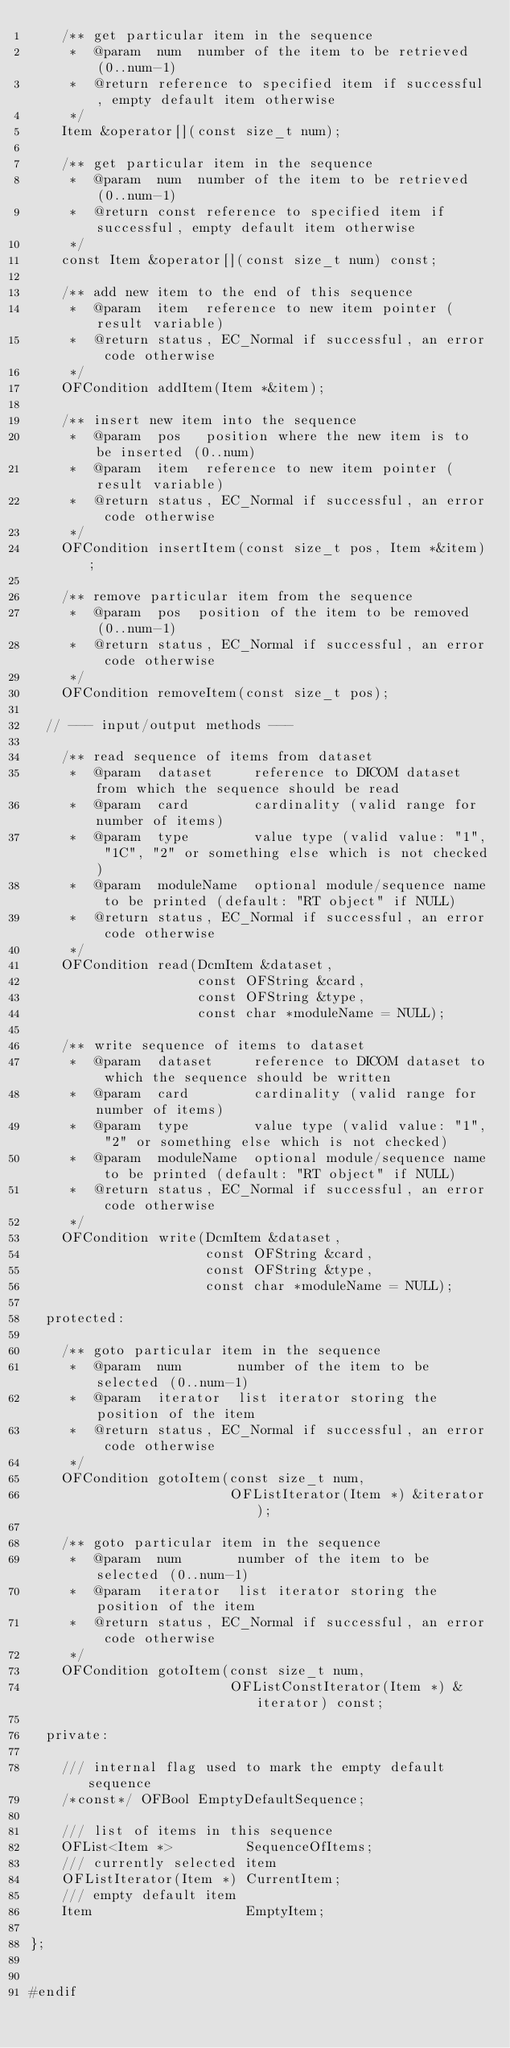<code> <loc_0><loc_0><loc_500><loc_500><_C_>    /** get particular item in the sequence
     *  @param  num  number of the item to be retrieved (0..num-1)
     *  @return reference to specified item if successful, empty default item otherwise
     */
    Item &operator[](const size_t num);

    /** get particular item in the sequence
     *  @param  num  number of the item to be retrieved (0..num-1)
     *  @return const reference to specified item if successful, empty default item otherwise
     */
    const Item &operator[](const size_t num) const;

    /** add new item to the end of this sequence
     *  @param  item  reference to new item pointer (result variable)
     *  @return status, EC_Normal if successful, an error code otherwise
     */
    OFCondition addItem(Item *&item);

    /** insert new item into the sequence
     *  @param  pos   position where the new item is to be inserted (0..num)
     *  @param  item  reference to new item pointer (result variable)
     *  @return status, EC_Normal if successful, an error code otherwise
     */
    OFCondition insertItem(const size_t pos, Item *&item);

    /** remove particular item from the sequence
     *  @param  pos  position of the item to be removed (0..num-1)
     *  @return status, EC_Normal if successful, an error code otherwise
     */
    OFCondition removeItem(const size_t pos);

  // --- input/output methods ---

    /** read sequence of items from dataset
     *  @param  dataset     reference to DICOM dataset from which the sequence should be read
     *  @param  card        cardinality (valid range for number of items)
     *  @param  type        value type (valid value: "1", "1C", "2" or something else which is not checked)
     *  @param  moduleName  optional module/sequence name to be printed (default: "RT object" if NULL)
     *  @return status, EC_Normal if successful, an error code otherwise
     */
    OFCondition read(DcmItem &dataset,
                     const OFString &card,
                     const OFString &type,
                     const char *moduleName = NULL);

    /** write sequence of items to dataset
     *  @param  dataset     reference to DICOM dataset to which the sequence should be written
     *  @param  card        cardinality (valid range for number of items)
     *  @param  type        value type (valid value: "1", "2" or something else which is not checked)
     *  @param  moduleName  optional module/sequence name to be printed (default: "RT object" if NULL)
     *  @return status, EC_Normal if successful, an error code otherwise
     */
    OFCondition write(DcmItem &dataset,
                      const OFString &card,
                      const OFString &type,
                      const char *moduleName = NULL);

  protected:

    /** goto particular item in the sequence
     *  @param  num       number of the item to be selected (0..num-1)
     *  @param  iterator  list iterator storing the position of the item
     *  @return status, EC_Normal if successful, an error code otherwise
     */
    OFCondition gotoItem(const size_t num,
                         OFListIterator(Item *) &iterator);

    /** goto particular item in the sequence
     *  @param  num       number of the item to be selected (0..num-1)
     *  @param  iterator  list iterator storing the position of the item
     *  @return status, EC_Normal if successful, an error code otherwise
     */
    OFCondition gotoItem(const size_t num,
                         OFListConstIterator(Item *) &iterator) const;

  private:

    /// internal flag used to mark the empty default sequence
    /*const*/ OFBool EmptyDefaultSequence;

    /// list of items in this sequence
    OFList<Item *>         SequenceOfItems;
    /// currently selected item
    OFListIterator(Item *) CurrentItem;
    /// empty default item
    Item                   EmptyItem;

};


#endif
</code> 